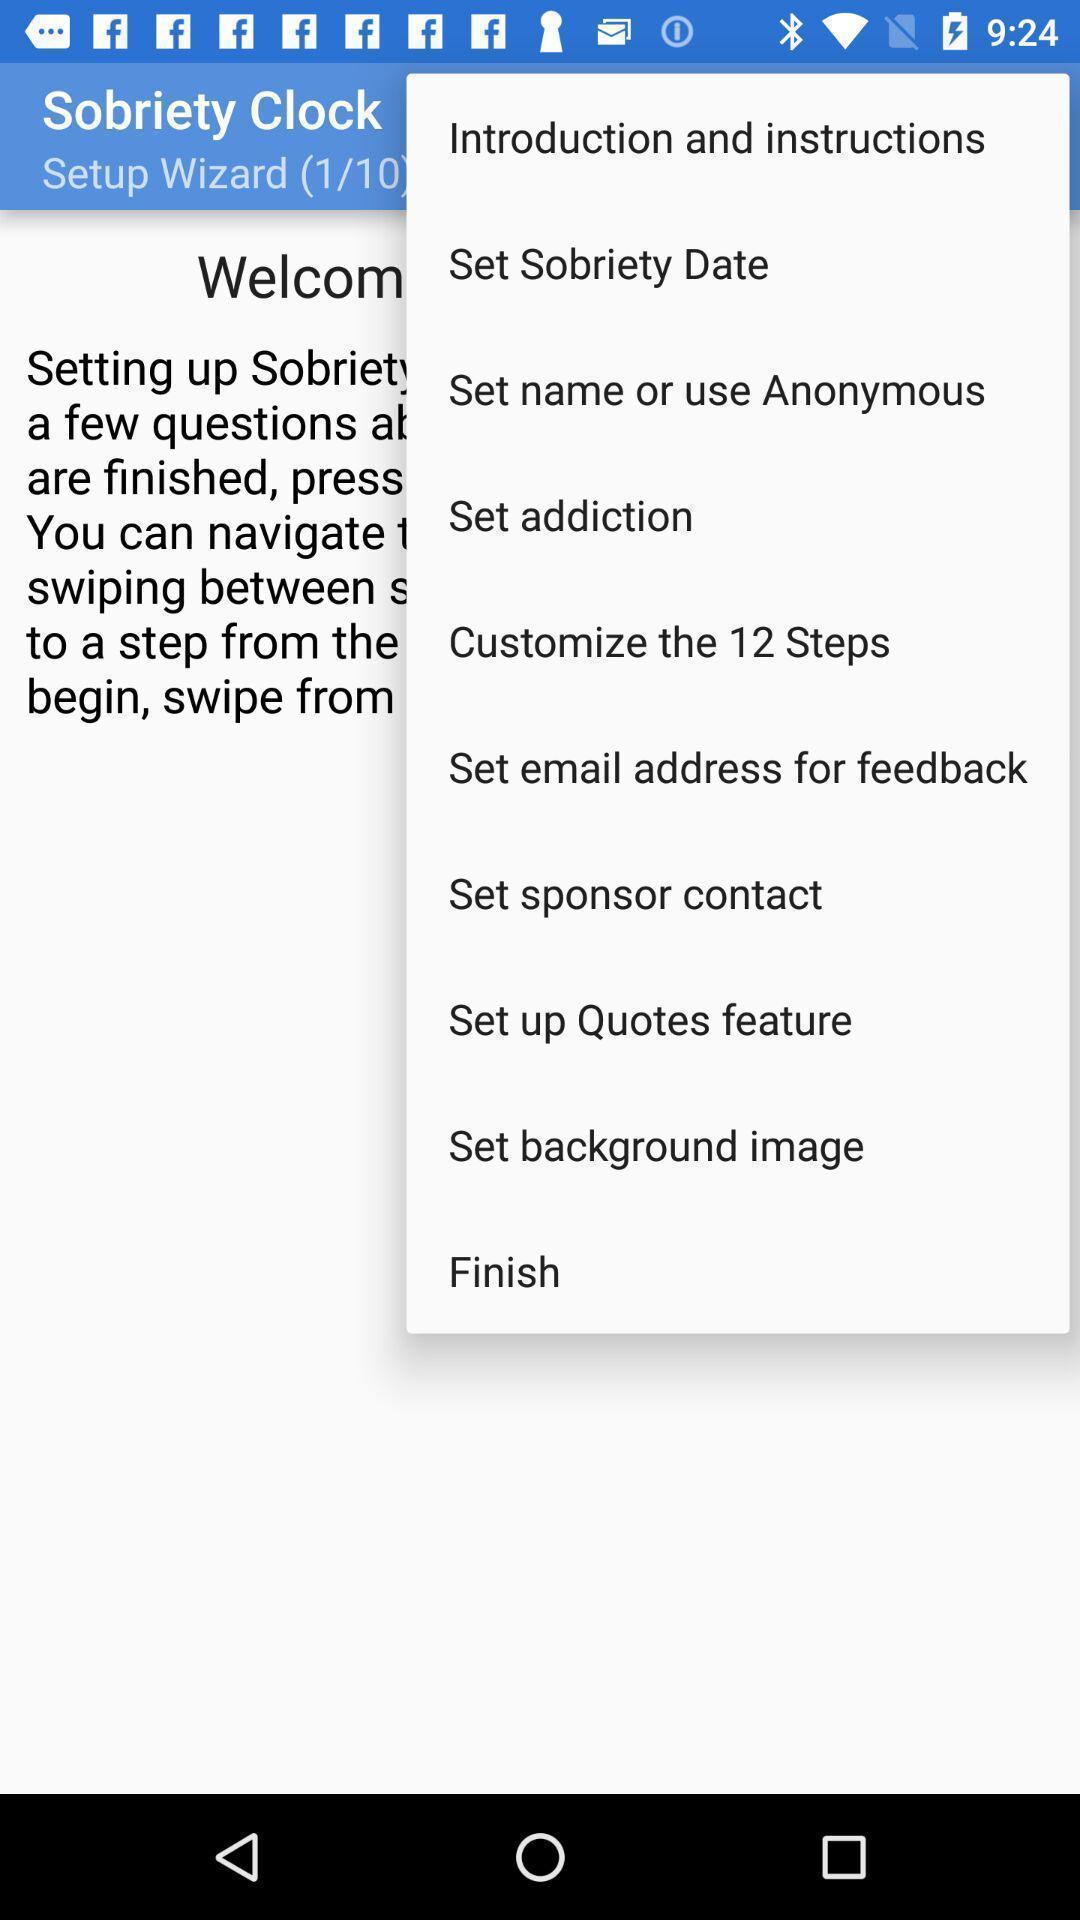Please provide a description for this image. Screen showing options. 